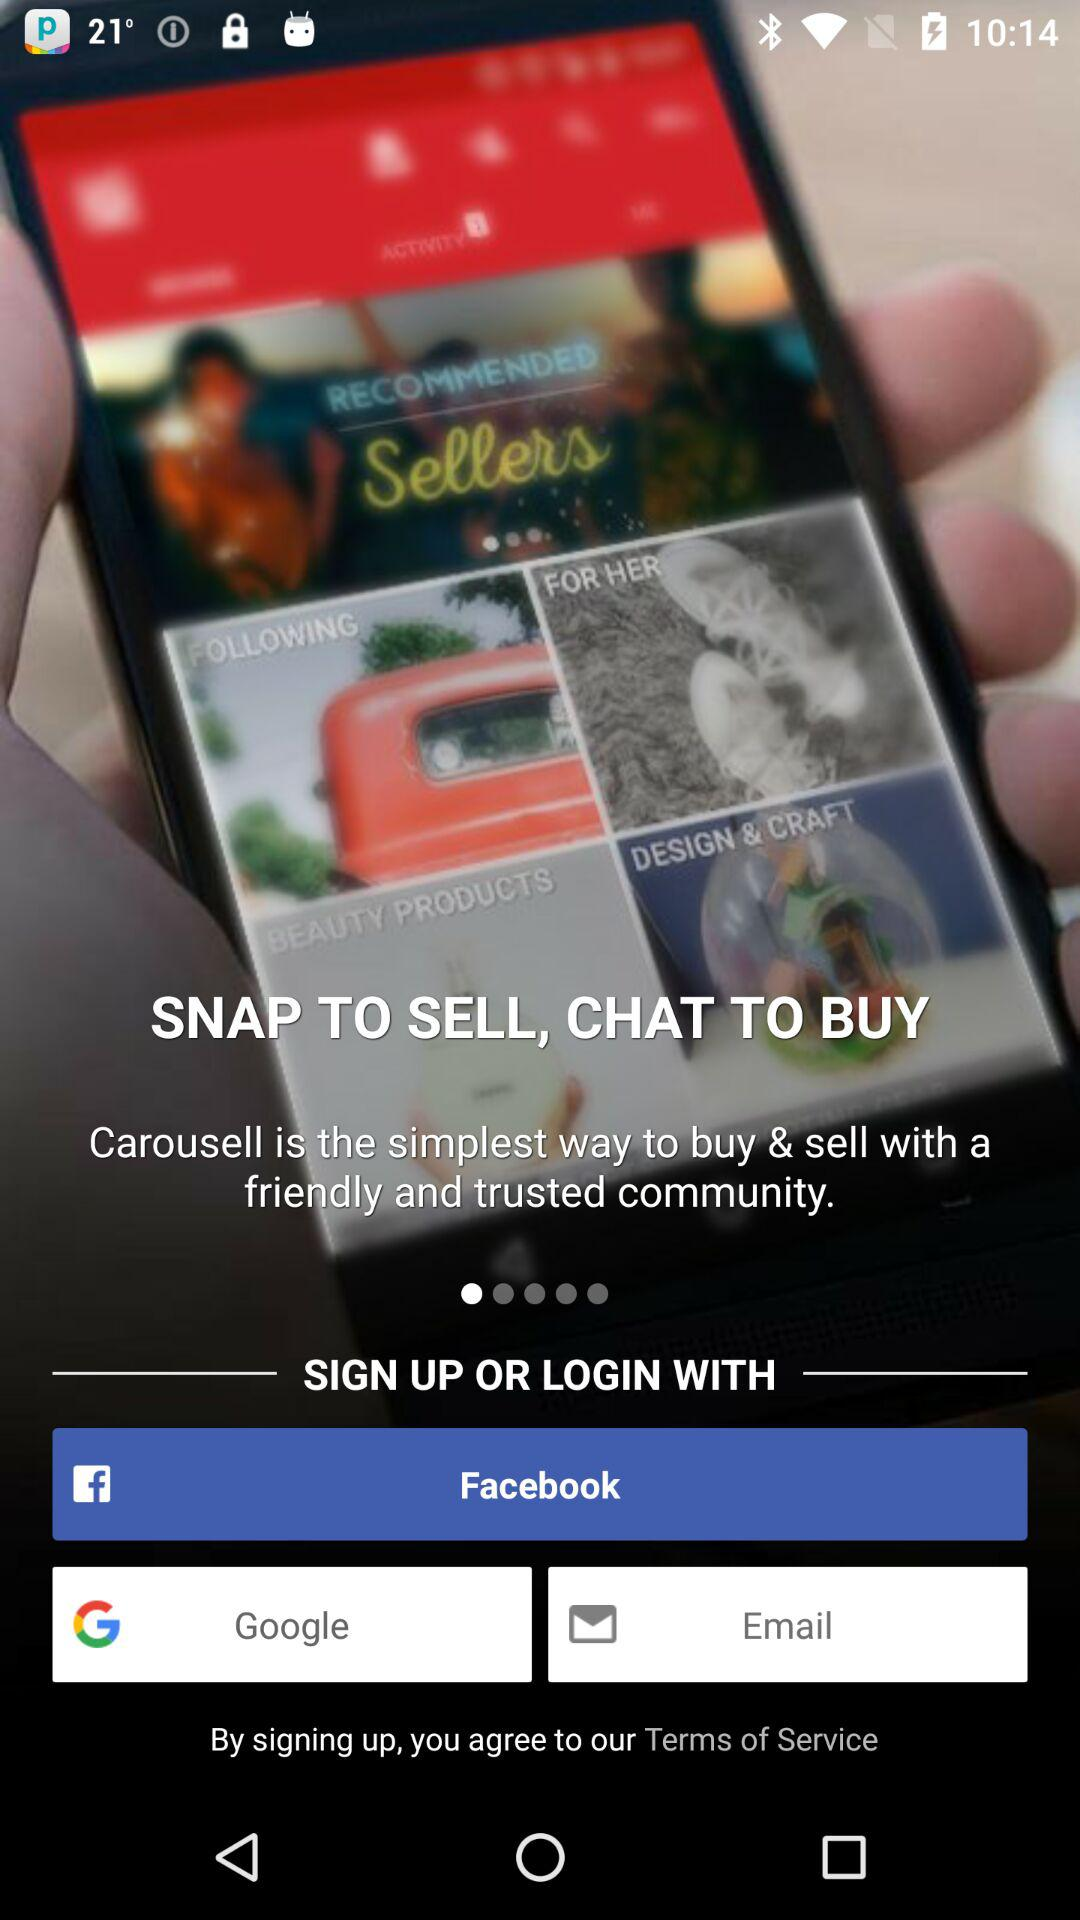What are the different applications through which we can log in? The different applications are "Facebook", "Google" and "Email". 